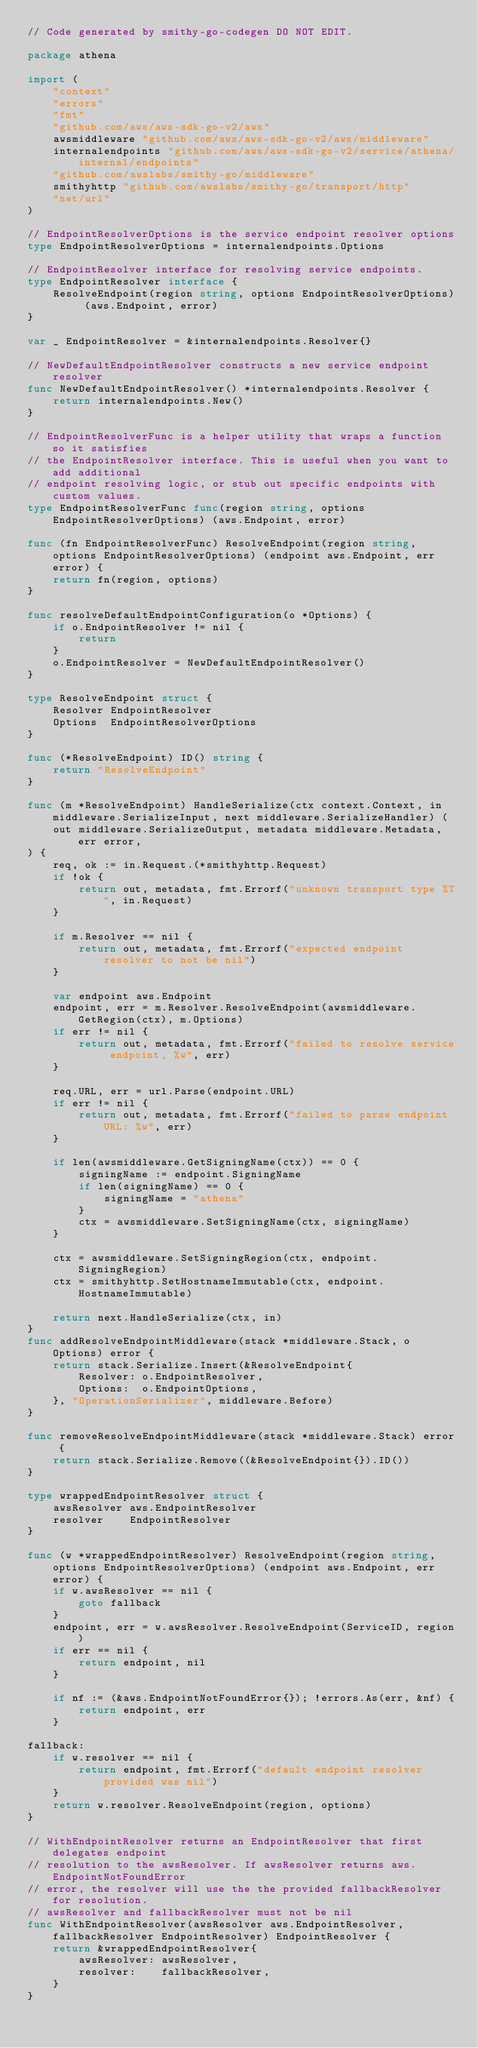<code> <loc_0><loc_0><loc_500><loc_500><_Go_>// Code generated by smithy-go-codegen DO NOT EDIT.

package athena

import (
	"context"
	"errors"
	"fmt"
	"github.com/aws/aws-sdk-go-v2/aws"
	awsmiddleware "github.com/aws/aws-sdk-go-v2/aws/middleware"
	internalendpoints "github.com/aws/aws-sdk-go-v2/service/athena/internal/endpoints"
	"github.com/awslabs/smithy-go/middleware"
	smithyhttp "github.com/awslabs/smithy-go/transport/http"
	"net/url"
)

// EndpointResolverOptions is the service endpoint resolver options
type EndpointResolverOptions = internalendpoints.Options

// EndpointResolver interface for resolving service endpoints.
type EndpointResolver interface {
	ResolveEndpoint(region string, options EndpointResolverOptions) (aws.Endpoint, error)
}

var _ EndpointResolver = &internalendpoints.Resolver{}

// NewDefaultEndpointResolver constructs a new service endpoint resolver
func NewDefaultEndpointResolver() *internalendpoints.Resolver {
	return internalendpoints.New()
}

// EndpointResolverFunc is a helper utility that wraps a function so it satisfies
// the EndpointResolver interface. This is useful when you want to add additional
// endpoint resolving logic, or stub out specific endpoints with custom values.
type EndpointResolverFunc func(region string, options EndpointResolverOptions) (aws.Endpoint, error)

func (fn EndpointResolverFunc) ResolveEndpoint(region string, options EndpointResolverOptions) (endpoint aws.Endpoint, err error) {
	return fn(region, options)
}

func resolveDefaultEndpointConfiguration(o *Options) {
	if o.EndpointResolver != nil {
		return
	}
	o.EndpointResolver = NewDefaultEndpointResolver()
}

type ResolveEndpoint struct {
	Resolver EndpointResolver
	Options  EndpointResolverOptions
}

func (*ResolveEndpoint) ID() string {
	return "ResolveEndpoint"
}

func (m *ResolveEndpoint) HandleSerialize(ctx context.Context, in middleware.SerializeInput, next middleware.SerializeHandler) (
	out middleware.SerializeOutput, metadata middleware.Metadata, err error,
) {
	req, ok := in.Request.(*smithyhttp.Request)
	if !ok {
		return out, metadata, fmt.Errorf("unknown transport type %T", in.Request)
	}

	if m.Resolver == nil {
		return out, metadata, fmt.Errorf("expected endpoint resolver to not be nil")
	}

	var endpoint aws.Endpoint
	endpoint, err = m.Resolver.ResolveEndpoint(awsmiddleware.GetRegion(ctx), m.Options)
	if err != nil {
		return out, metadata, fmt.Errorf("failed to resolve service endpoint, %w", err)
	}

	req.URL, err = url.Parse(endpoint.URL)
	if err != nil {
		return out, metadata, fmt.Errorf("failed to parse endpoint URL: %w", err)
	}

	if len(awsmiddleware.GetSigningName(ctx)) == 0 {
		signingName := endpoint.SigningName
		if len(signingName) == 0 {
			signingName = "athena"
		}
		ctx = awsmiddleware.SetSigningName(ctx, signingName)
	}

	ctx = awsmiddleware.SetSigningRegion(ctx, endpoint.SigningRegion)
	ctx = smithyhttp.SetHostnameImmutable(ctx, endpoint.HostnameImmutable)

	return next.HandleSerialize(ctx, in)
}
func addResolveEndpointMiddleware(stack *middleware.Stack, o Options) error {
	return stack.Serialize.Insert(&ResolveEndpoint{
		Resolver: o.EndpointResolver,
		Options:  o.EndpointOptions,
	}, "OperationSerializer", middleware.Before)
}

func removeResolveEndpointMiddleware(stack *middleware.Stack) error {
	return stack.Serialize.Remove((&ResolveEndpoint{}).ID())
}

type wrappedEndpointResolver struct {
	awsResolver aws.EndpointResolver
	resolver    EndpointResolver
}

func (w *wrappedEndpointResolver) ResolveEndpoint(region string, options EndpointResolverOptions) (endpoint aws.Endpoint, err error) {
	if w.awsResolver == nil {
		goto fallback
	}
	endpoint, err = w.awsResolver.ResolveEndpoint(ServiceID, region)
	if err == nil {
		return endpoint, nil
	}

	if nf := (&aws.EndpointNotFoundError{}); !errors.As(err, &nf) {
		return endpoint, err
	}

fallback:
	if w.resolver == nil {
		return endpoint, fmt.Errorf("default endpoint resolver provided was nil")
	}
	return w.resolver.ResolveEndpoint(region, options)
}

// WithEndpointResolver returns an EndpointResolver that first delegates endpoint
// resolution to the awsResolver. If awsResolver returns aws.EndpointNotFoundError
// error, the resolver will use the the provided fallbackResolver for resolution.
// awsResolver and fallbackResolver must not be nil
func WithEndpointResolver(awsResolver aws.EndpointResolver, fallbackResolver EndpointResolver) EndpointResolver {
	return &wrappedEndpointResolver{
		awsResolver: awsResolver,
		resolver:    fallbackResolver,
	}
}
</code> 